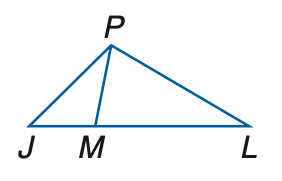Answer the mathemtical geometry problem and directly provide the correct option letter.
Question: In the figure, J M \cong P M and M L \cong P L. If m \angle P L J = 58, find m \angle P J L.
Choices: A: 27.5 B: 28.5 C: 29.5 D: 30.5 D 